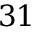<formula> <loc_0><loc_0><loc_500><loc_500>3 1</formula> 